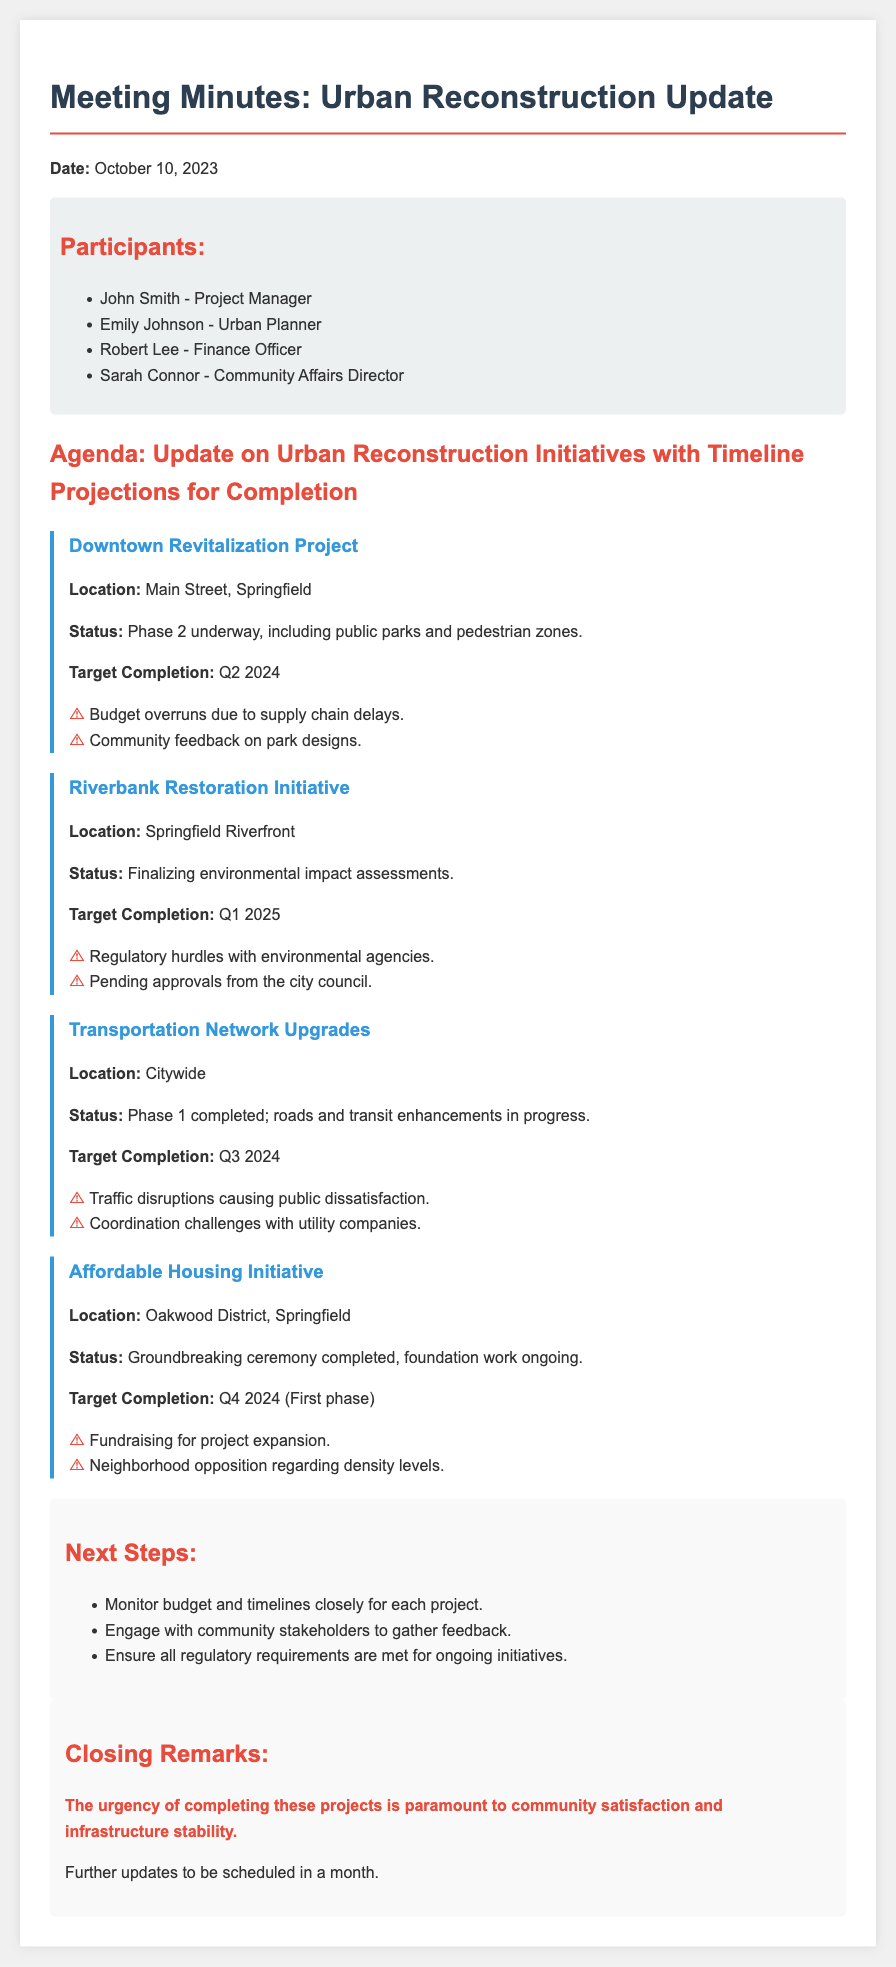What is the target completion date for the Downtown Revitalization Project? The target completion date is explicitly stated in the document under the project status.
Answer: Q2 2024 What is the status of the Riverbank Restoration Initiative? The status is provided in the project details, indicating the current phase of the project.
Answer: Finalizing environmental impact assessments Who is the Project Manager? The name of the Project Manager is listed in the participants section of the document.
Answer: John Smith What are the key issues for the Transportation Network Upgrades? The document lists specific challenges faced by the project under key issues.
Answer: Traffic disruptions causing public dissatisfaction, Coordination challenges with utility companies What is the urgency expressed in the closing remarks? The closing remarks highlight the overall sentiment around the projects and their impacts.
Answer: The urgency of completing these projects is paramount to community satisfaction and infrastructure stability What is the funding challenge for the Affordable Housing Initiative? The document specifically mentions a key issue related to funding for expansion in the project details.
Answer: Fundraising for project expansion In what phase is the Downtown Revitalization Project currently? The current phase of the project is detailed within the project description section.
Answer: Phase 2 underway Which initiative has a target completion in Q1 2025? The target completion dates for projects are listed, enabling identification of the initiative for that period.
Answer: Riverbank Restoration Initiative 